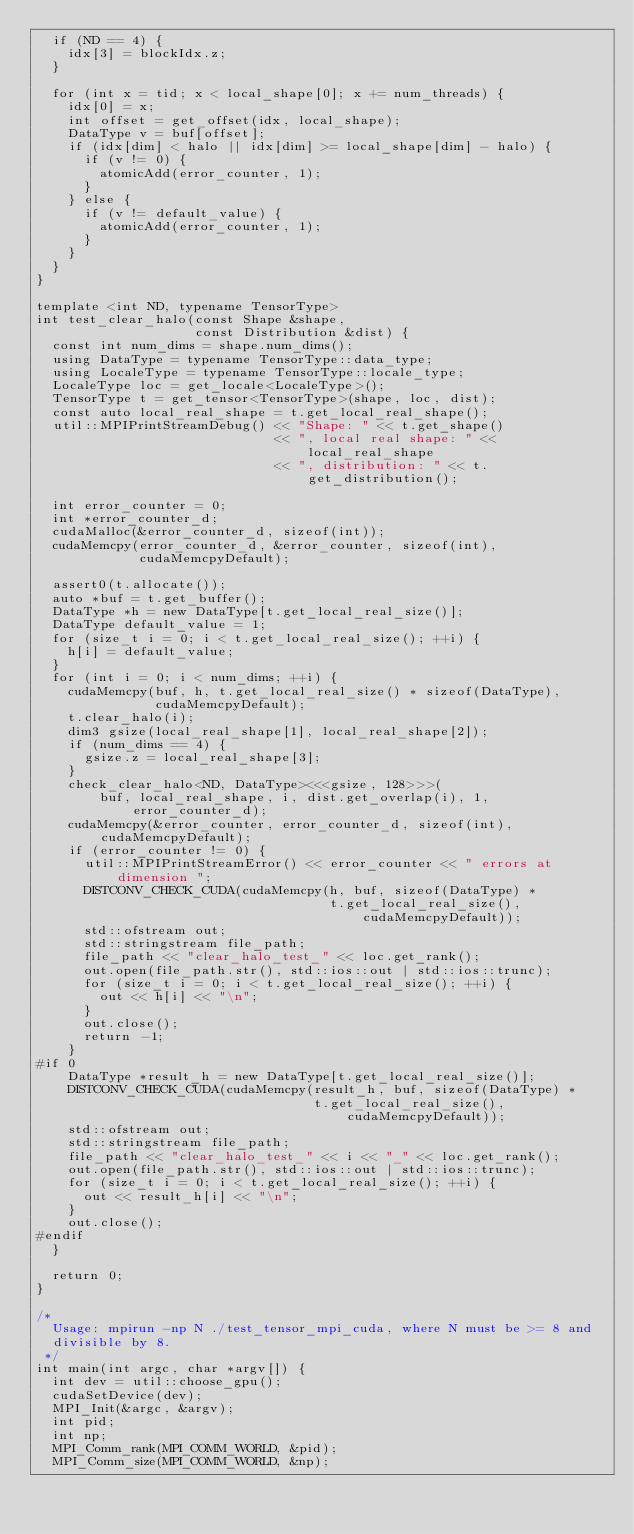<code> <loc_0><loc_0><loc_500><loc_500><_Cuda_>  if (ND == 4) {
    idx[3] = blockIdx.z;
  }

  for (int x = tid; x < local_shape[0]; x += num_threads) {
    idx[0] = x;
    int offset = get_offset(idx, local_shape);
    DataType v = buf[offset];
    if (idx[dim] < halo || idx[dim] >= local_shape[dim] - halo) {
      if (v != 0) {
        atomicAdd(error_counter, 1);
      }
    } else {
      if (v != default_value) {
        atomicAdd(error_counter, 1);
      }
    }
  }
}

template <int ND, typename TensorType>
int test_clear_halo(const Shape &shape,
                    const Distribution &dist) {
  const int num_dims = shape.num_dims();
  using DataType = typename TensorType::data_type;
  using LocaleType = typename TensorType::locale_type;
  LocaleType loc = get_locale<LocaleType>();
  TensorType t = get_tensor<TensorType>(shape, loc, dist);
  const auto local_real_shape = t.get_local_real_shape();
  util::MPIPrintStreamDebug() << "Shape: " << t.get_shape()
                              << ", local real shape: " << local_real_shape
                              << ", distribution: " << t.get_distribution();

  int error_counter = 0;
  int *error_counter_d;
  cudaMalloc(&error_counter_d, sizeof(int));
  cudaMemcpy(error_counter_d, &error_counter, sizeof(int),
             cudaMemcpyDefault);

  assert0(t.allocate());
  auto *buf = t.get_buffer();
  DataType *h = new DataType[t.get_local_real_size()];
  DataType default_value = 1;
  for (size_t i = 0; i < t.get_local_real_size(); ++i) {
    h[i] = default_value;
  }
  for (int i = 0; i < num_dims; ++i) {
    cudaMemcpy(buf, h, t.get_local_real_size() * sizeof(DataType),
               cudaMemcpyDefault);
    t.clear_halo(i);
    dim3 gsize(local_real_shape[1], local_real_shape[2]);
    if (num_dims == 4) {
      gsize.z = local_real_shape[3];
    }
    check_clear_halo<ND, DataType><<<gsize, 128>>>(
        buf, local_real_shape, i, dist.get_overlap(i), 1, error_counter_d);
    cudaMemcpy(&error_counter, error_counter_d, sizeof(int), cudaMemcpyDefault);
    if (error_counter != 0) {
      util::MPIPrintStreamError() << error_counter << " errors at dimension ";
      DISTCONV_CHECK_CUDA(cudaMemcpy(h, buf, sizeof(DataType) *
                                     t.get_local_real_size(), cudaMemcpyDefault));
      std::ofstream out;
      std::stringstream file_path;
      file_path << "clear_halo_test_" << loc.get_rank();
      out.open(file_path.str(), std::ios::out | std::ios::trunc);
      for (size_t i = 0; i < t.get_local_real_size(); ++i) {
        out << h[i] << "\n";
      }
      out.close();
      return -1;
    }
#if 0
    DataType *result_h = new DataType[t.get_local_real_size()];
    DISTCONV_CHECK_CUDA(cudaMemcpy(result_h, buf, sizeof(DataType) *
                                   t.get_local_real_size(), cudaMemcpyDefault));
    std::ofstream out;
    std::stringstream file_path;
    file_path << "clear_halo_test_" << i << "_" << loc.get_rank();
    out.open(file_path.str(), std::ios::out | std::ios::trunc);
    for (size_t i = 0; i < t.get_local_real_size(); ++i) {
      out << result_h[i] << "\n";
    }
    out.close();
#endif
  }

  return 0;
}

/*
  Usage: mpirun -np N ./test_tensor_mpi_cuda, where N must be >= 8 and
  divisible by 8.
 */
int main(int argc, char *argv[]) {
  int dev = util::choose_gpu();
  cudaSetDevice(dev);
  MPI_Init(&argc, &argv);
  int pid;
  int np;
  MPI_Comm_rank(MPI_COMM_WORLD, &pid);
  MPI_Comm_size(MPI_COMM_WORLD, &np);
</code> 